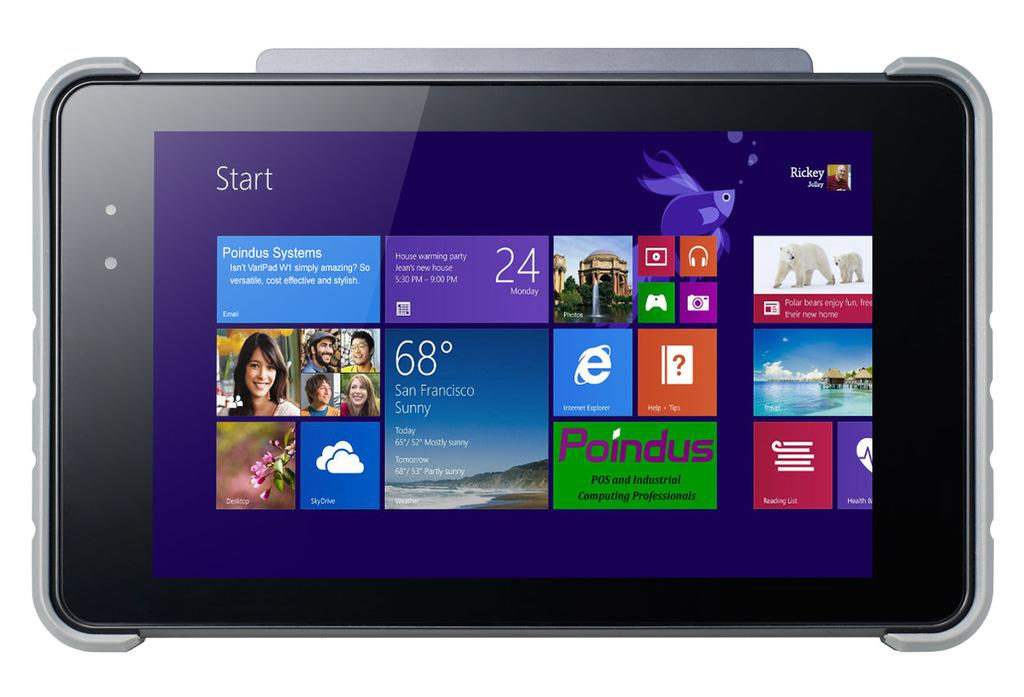What is the main object in the image? There is a screen in the image. What can be seen on the screen? Images, texts, and numbers are visible on the screen. How many tomatoes are hanging from the trees in the image? There are no tomatoes or trees present in the image; it only features a screen with images, texts, and numbers. 